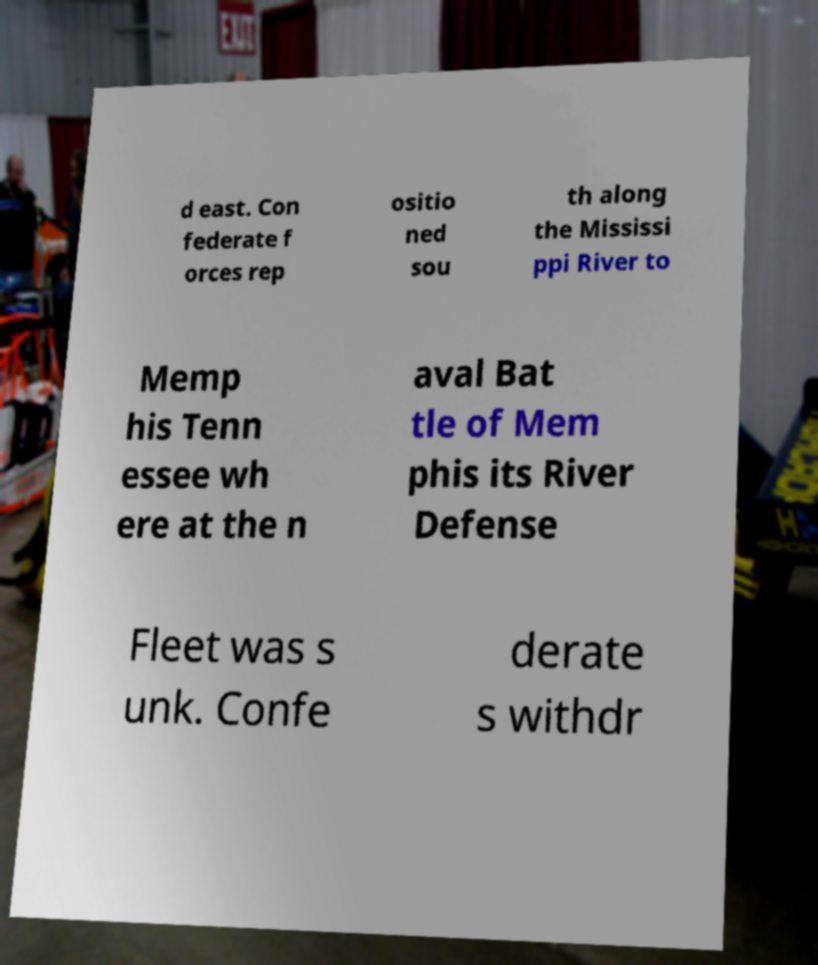I need the written content from this picture converted into text. Can you do that? d east. Con federate f orces rep ositio ned sou th along the Mississi ppi River to Memp his Tenn essee wh ere at the n aval Bat tle of Mem phis its River Defense Fleet was s unk. Confe derate s withdr 